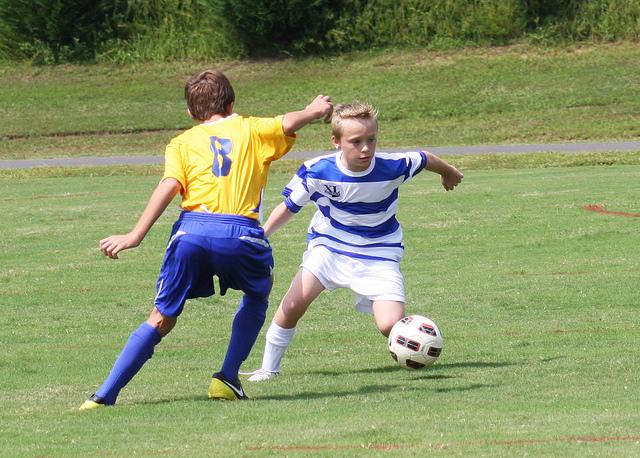Are these kids on the same team?
Answer briefly. No. What sport is being played?
Give a very brief answer. Soccer. How many players are wearing yellow?
Short answer required. 1. Are they angry at each other?
Be succinct. No. What sport is shown?
Give a very brief answer. Soccer. What color is the ball?
Concise answer only. White. 